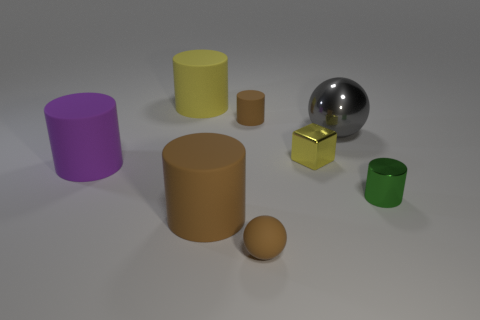There is a small matte object that is the same color as the small matte sphere; what is its shape?
Your answer should be very brief. Cylinder. What is the size of the ball behind the large brown object?
Keep it short and to the point. Large. How many gray things are either small balls or tiny metallic objects?
Keep it short and to the point. 0. There is a green thing that is the same shape as the yellow rubber thing; what is it made of?
Provide a short and direct response. Metal. Are there an equal number of small brown spheres behind the small brown matte cylinder and large red matte balls?
Give a very brief answer. Yes. What is the size of the matte cylinder that is on the right side of the yellow rubber object and in front of the metallic ball?
Provide a short and direct response. Large. Is there anything else that is the same color as the tiny shiny cube?
Your response must be concise. Yes. There is a ball that is behind the big cylinder that is in front of the tiny green object; what is its size?
Your answer should be compact. Large. What color is the big thing that is behind the tiny cube and to the left of the gray thing?
Keep it short and to the point. Yellow. How many other objects are the same size as the yellow cube?
Your answer should be compact. 3. 